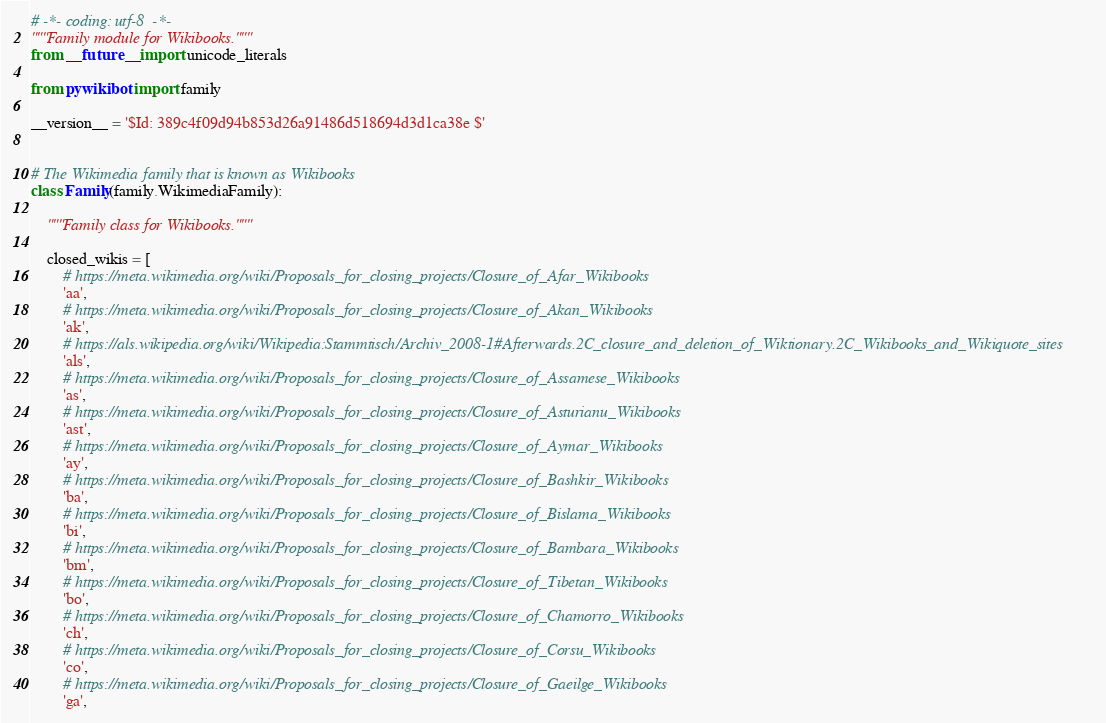<code> <loc_0><loc_0><loc_500><loc_500><_Python_># -*- coding: utf-8  -*-
"""Family module for Wikibooks."""
from __future__ import unicode_literals

from pywikibot import family

__version__ = '$Id: 389c4f09d94b853d26a91486d518694d3d1ca38e $'


# The Wikimedia family that is known as Wikibooks
class Family(family.WikimediaFamily):

    """Family class for Wikibooks."""

    closed_wikis = [
        # https://meta.wikimedia.org/wiki/Proposals_for_closing_projects/Closure_of_Afar_Wikibooks
        'aa',
        # https://meta.wikimedia.org/wiki/Proposals_for_closing_projects/Closure_of_Akan_Wikibooks
        'ak',
        # https://als.wikipedia.org/wiki/Wikipedia:Stammtisch/Archiv_2008-1#Afterwards.2C_closure_and_deletion_of_Wiktionary.2C_Wikibooks_and_Wikiquote_sites
        'als',
        # https://meta.wikimedia.org/wiki/Proposals_for_closing_projects/Closure_of_Assamese_Wikibooks
        'as',
        # https://meta.wikimedia.org/wiki/Proposals_for_closing_projects/Closure_of_Asturianu_Wikibooks
        'ast',
        # https://meta.wikimedia.org/wiki/Proposals_for_closing_projects/Closure_of_Aymar_Wikibooks
        'ay',
        # https://meta.wikimedia.org/wiki/Proposals_for_closing_projects/Closure_of_Bashkir_Wikibooks
        'ba',
        # https://meta.wikimedia.org/wiki/Proposals_for_closing_projects/Closure_of_Bislama_Wikibooks
        'bi',
        # https://meta.wikimedia.org/wiki/Proposals_for_closing_projects/Closure_of_Bambara_Wikibooks
        'bm',
        # https://meta.wikimedia.org/wiki/Proposals_for_closing_projects/Closure_of_Tibetan_Wikibooks
        'bo',
        # https://meta.wikimedia.org/wiki/Proposals_for_closing_projects/Closure_of_Chamorro_Wikibooks
        'ch',
        # https://meta.wikimedia.org/wiki/Proposals_for_closing_projects/Closure_of_Corsu_Wikibooks
        'co',
        # https://meta.wikimedia.org/wiki/Proposals_for_closing_projects/Closure_of_Gaeilge_Wikibooks
        'ga',</code> 